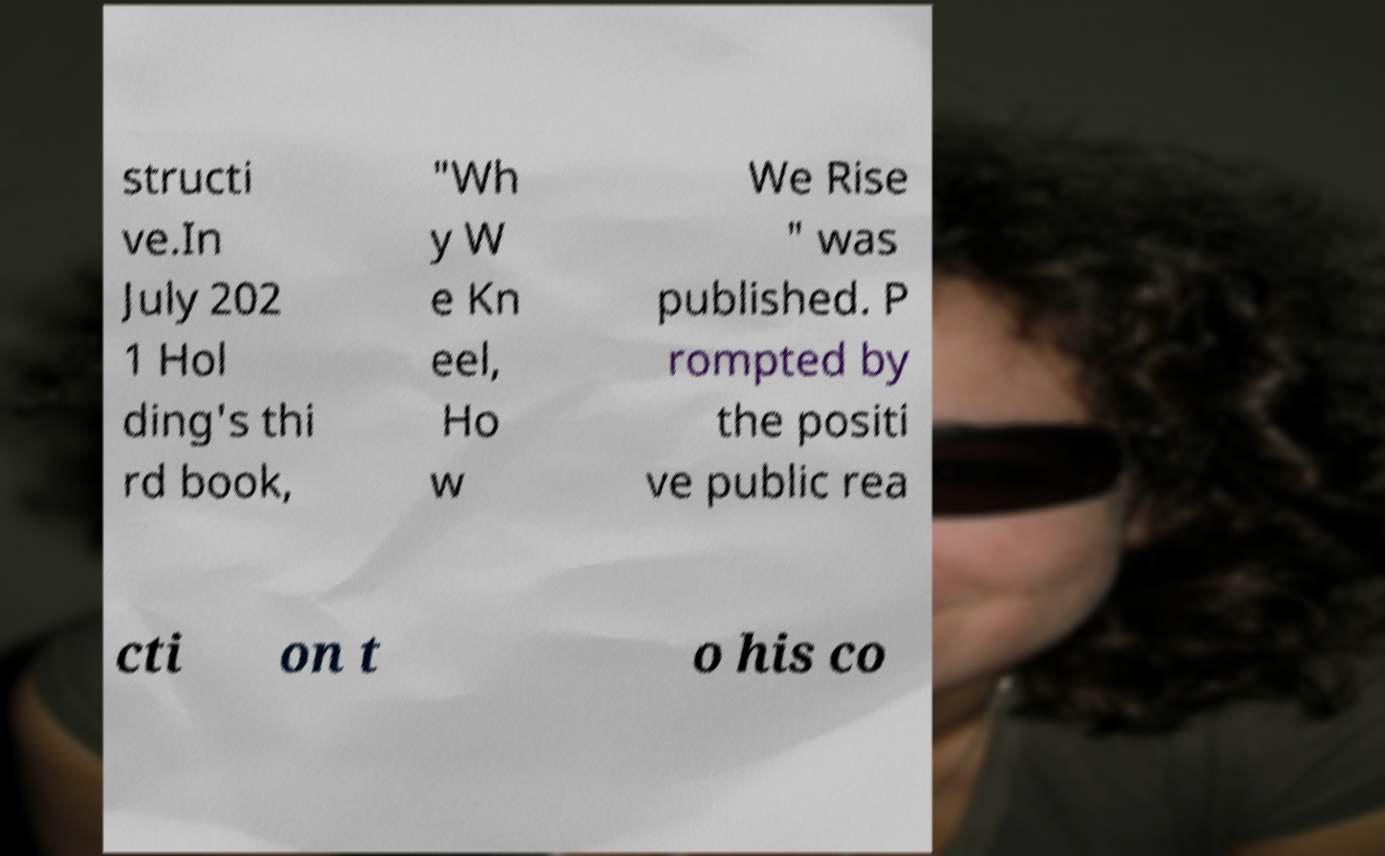Can you accurately transcribe the text from the provided image for me? structi ve.In July 202 1 Hol ding's thi rd book, "Wh y W e Kn eel, Ho w We Rise " was published. P rompted by the positi ve public rea cti on t o his co 